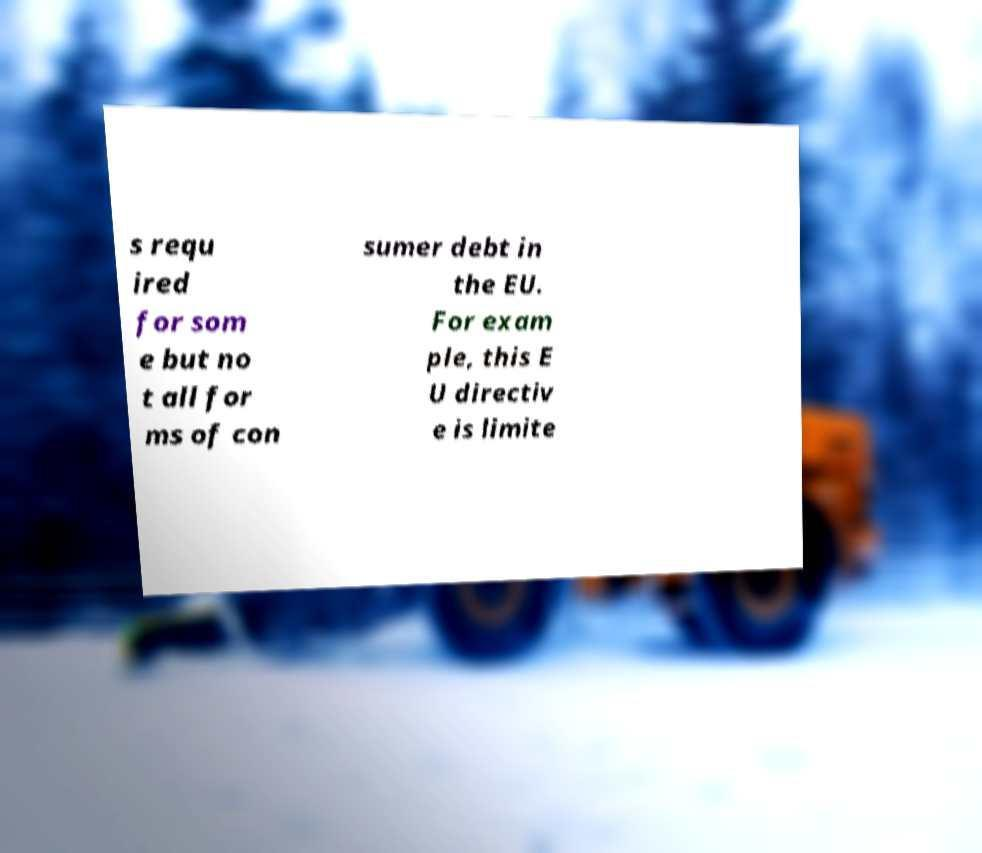Can you read and provide the text displayed in the image?This photo seems to have some interesting text. Can you extract and type it out for me? s requ ired for som e but no t all for ms of con sumer debt in the EU. For exam ple, this E U directiv e is limite 